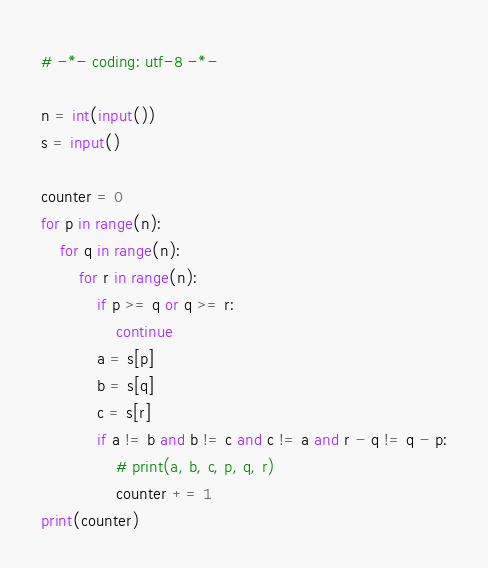Convert code to text. <code><loc_0><loc_0><loc_500><loc_500><_Python_># -*- coding: utf-8 -*-

n = int(input())
s = input()

counter = 0
for p in range(n):
    for q in range(n):
        for r in range(n):
            if p >= q or q >= r:
                continue
            a = s[p]
            b = s[q]
            c = s[r]
            if a != b and b != c and c != a and r - q != q - p:
                # print(a, b, c, p, q, r)
                counter += 1
print(counter)</code> 